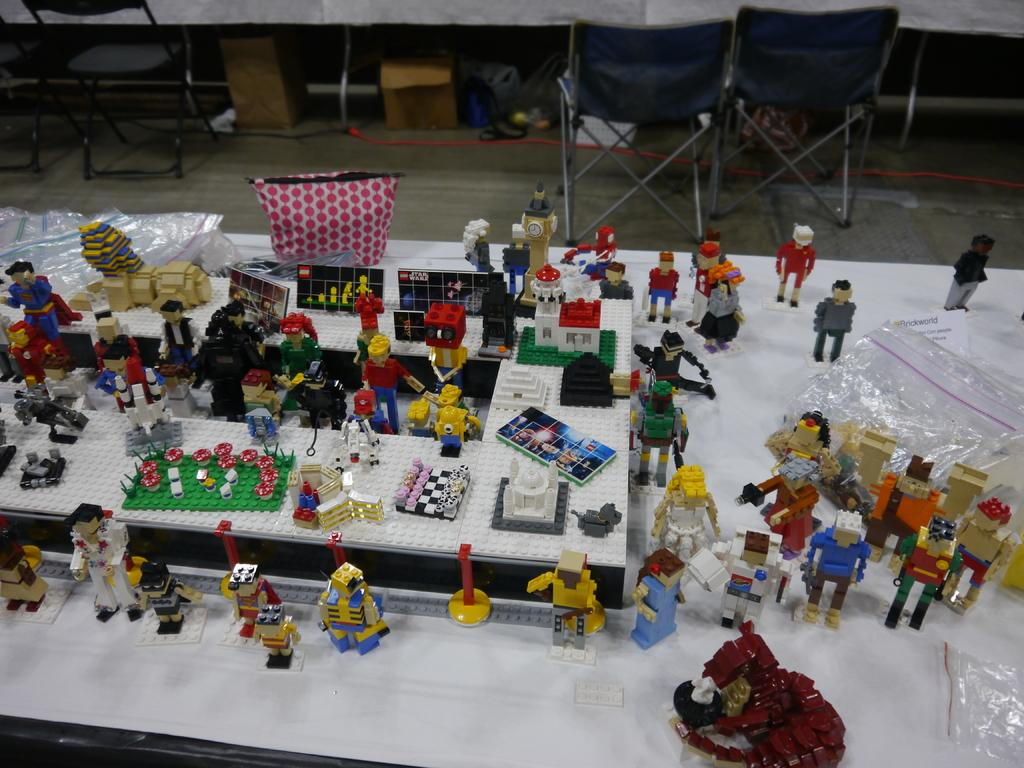What type of items can be seen on the table in the image? There are toys and covers on the table. Are there any other objects on the table besides toys and covers? Yes, there are other objects on the table. What can be seen in the background of the image? There are chairs and other objects in the background. How far away is the hydrant from the table in the image? There is no hydrant present in the image, so it is not possible to determine the distance between a hydrant and the table. 